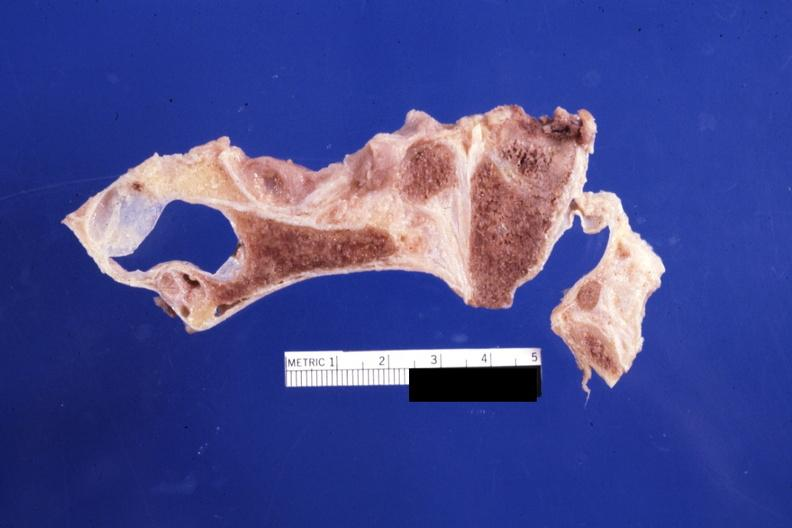s rheumatoid arthritis present?
Answer the question using a single word or phrase. Yes 